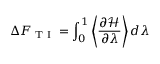<formula> <loc_0><loc_0><loc_500><loc_500>\Delta F _ { T I } = \int _ { 0 } ^ { 1 } \left \langle \frac { \partial \mathcal { H } } { \partial \lambda } \right \rangle d \lambda</formula> 